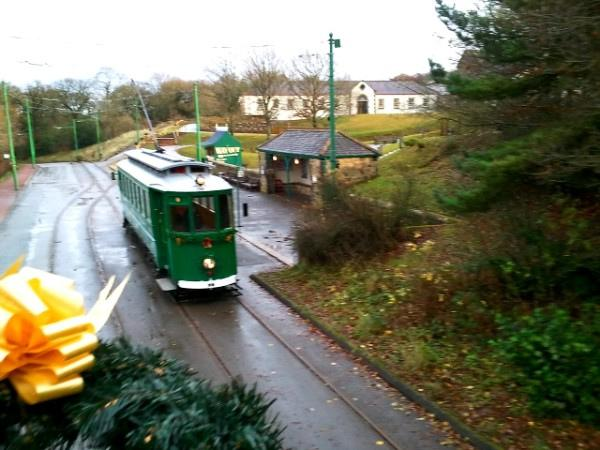What holiday is most likely next? Please explain your reasoning. christmas. There is a holiday wreath in the picture, which tells you the holiday coming. 